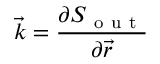<formula> <loc_0><loc_0><loc_500><loc_500>\vec { k } = \frac { \partial S _ { o u t } } { \partial \vec { r } }</formula> 